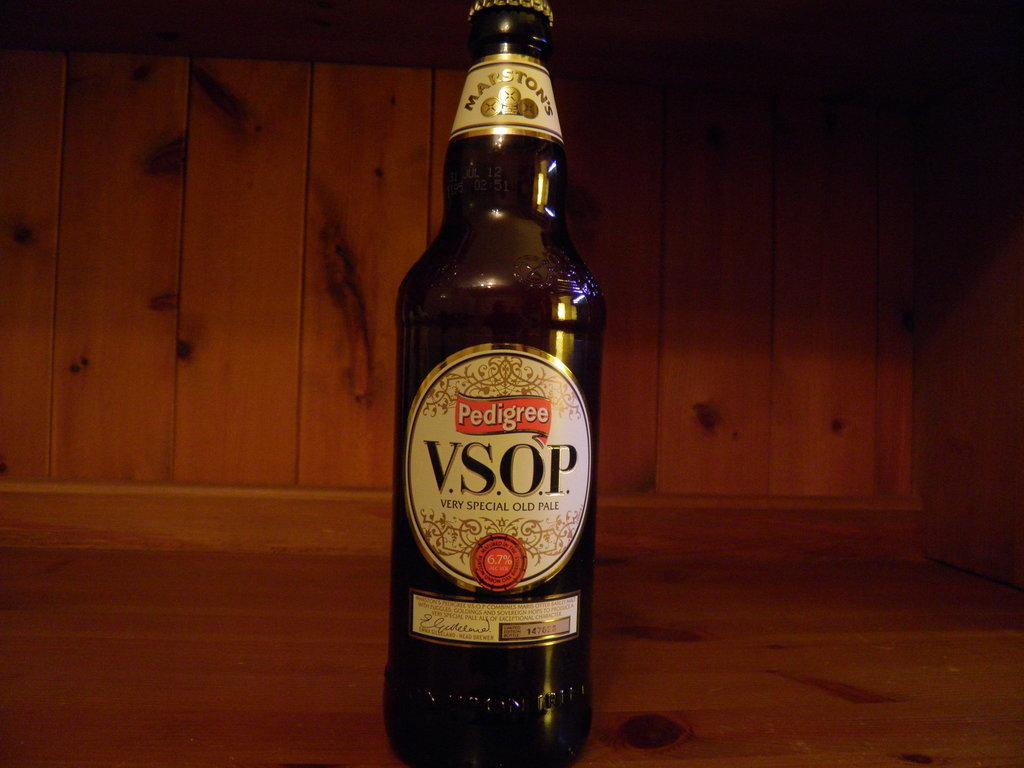<image>
Offer a succinct explanation of the picture presented. the letters vsop that are on a beer bottle 